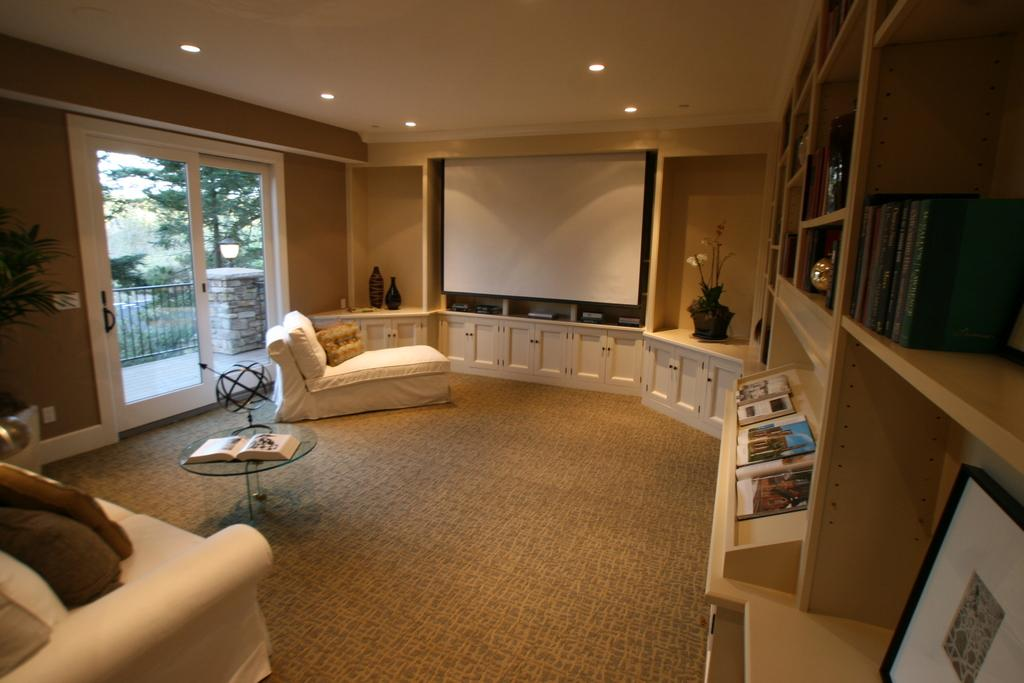What type of screen is present in the living room? There is a screen in the living room, but the specific type is not mentioned in the facts. What can be found near the screen in the living room? There is a bottle in the living room. What type of plant is in the living room? There is a plant in the living room, but the specific type is not mentioned in the facts. What type of storage furniture is in the living room? There is a cupboard in the living room. What type of reading material is in the living room? There are books in the living room. What type of furniture is used for holding items in the living room? There is a rack in the living room. What type of floor covering is in the living room? There is a carpet in the living room. What type of furniture is used for eating or working on in the living room? There is a table in the living room. What type of seating is in the living room? There is a couch in the living room. What type of decoration is on the couch in the living room? There are pillows on the couch. What can be seen through the window in the living room? There is a tree visible through the window. What type of lighting is in the living room? There is a light in the living room. What type of noise can be heard coming from the edge of the living room? There is no mention of any noise or edge in the living room, so it cannot be determined from the facts. 